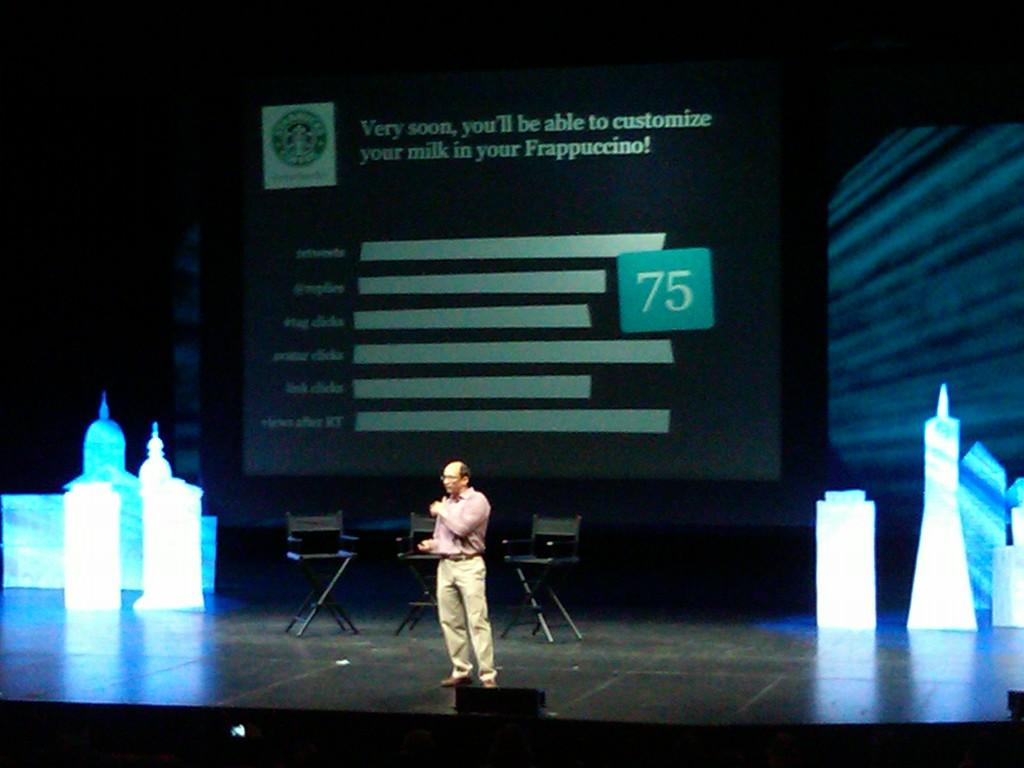What is the person in the image doing? There is a person standing on the stage in the image. What can be seen in the background of the image? There are chairs and a screen in the background. What type of boot is the person wearing on their neck in the image? There is no boot or any reference to a person's neck in the image. 